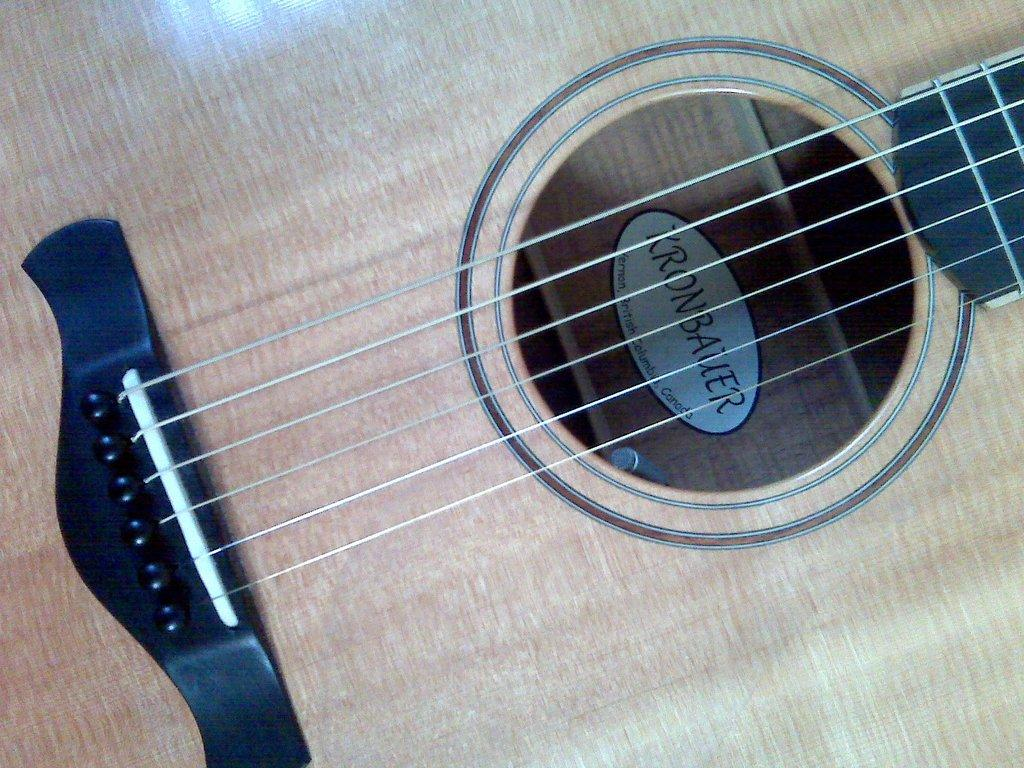What musical instrument is featured in the image? The image features a guitar. What part of the guitar is visible in the image? The strings of the guitar are visible in the image. How many trucks are parked near the sea in the image? There are no trucks or sea present in the image; it features a guitar with visible strings. 